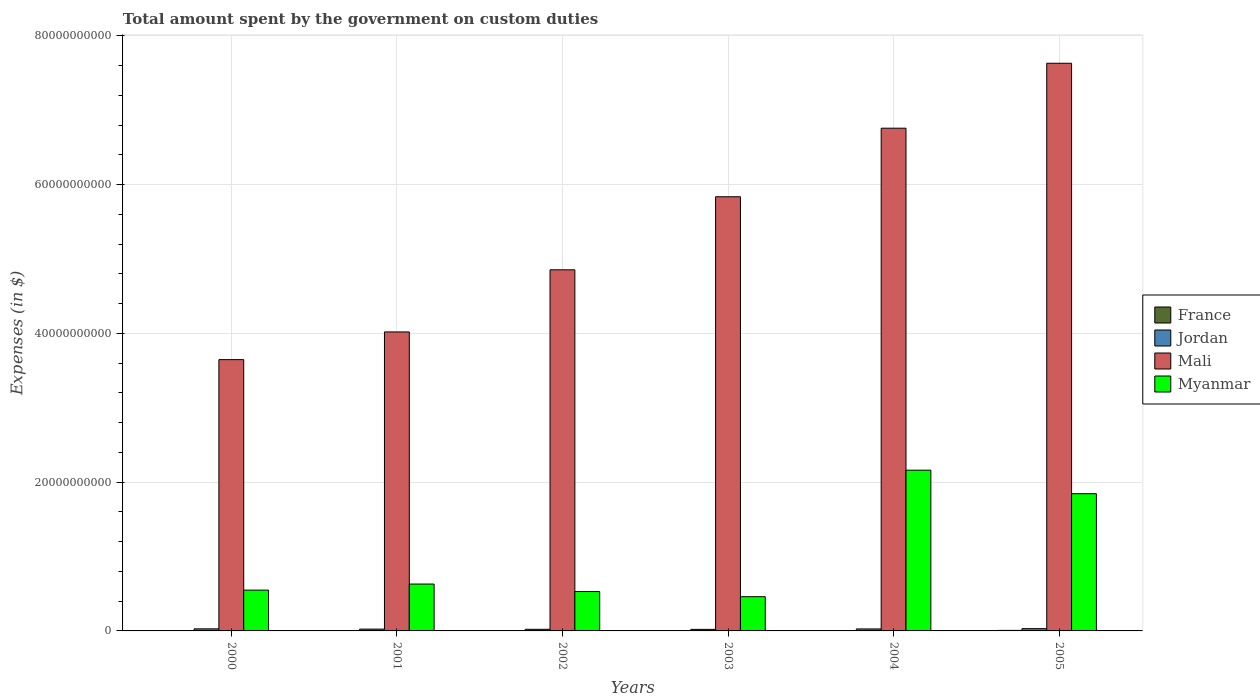How many different coloured bars are there?
Your response must be concise. 4. How many groups of bars are there?
Keep it short and to the point. 6. What is the label of the 4th group of bars from the left?
Provide a succinct answer. 2003. What is the amount spent on custom duties by the government in Mali in 2002?
Your answer should be compact. 4.86e+1. Across all years, what is the maximum amount spent on custom duties by the government in France?
Offer a terse response. 7.30e+07. Across all years, what is the minimum amount spent on custom duties by the government in Jordan?
Your response must be concise. 2.09e+08. What is the total amount spent on custom duties by the government in Myanmar in the graph?
Provide a short and direct response. 6.17e+1. What is the difference between the amount spent on custom duties by the government in Jordan in 2002 and that in 2004?
Ensure brevity in your answer.  -4.71e+07. What is the difference between the amount spent on custom duties by the government in Myanmar in 2003 and the amount spent on custom duties by the government in Jordan in 2004?
Give a very brief answer. 4.34e+09. What is the average amount spent on custom duties by the government in France per year?
Your response must be concise. 1.73e+07. In the year 2005, what is the difference between the amount spent on custom duties by the government in Myanmar and amount spent on custom duties by the government in Jordan?
Provide a short and direct response. 1.81e+1. What is the ratio of the amount spent on custom duties by the government in Myanmar in 2002 to that in 2003?
Provide a succinct answer. 1.15. Is the amount spent on custom duties by the government in Jordan in 2000 less than that in 2005?
Offer a terse response. Yes. Is the difference between the amount spent on custom duties by the government in Myanmar in 2002 and 2004 greater than the difference between the amount spent on custom duties by the government in Jordan in 2002 and 2004?
Ensure brevity in your answer.  No. What is the difference between the highest and the second highest amount spent on custom duties by the government in France?
Your answer should be compact. 5.40e+07. What is the difference between the highest and the lowest amount spent on custom duties by the government in Mali?
Your answer should be compact. 3.98e+1. Is it the case that in every year, the sum of the amount spent on custom duties by the government in Mali and amount spent on custom duties by the government in Jordan is greater than the sum of amount spent on custom duties by the government in Myanmar and amount spent on custom duties by the government in France?
Your answer should be very brief. Yes. How many bars are there?
Provide a short and direct response. 22. Are all the bars in the graph horizontal?
Give a very brief answer. No. What is the difference between two consecutive major ticks on the Y-axis?
Ensure brevity in your answer.  2.00e+1. Does the graph contain any zero values?
Offer a very short reply. Yes. Does the graph contain grids?
Give a very brief answer. Yes. Where does the legend appear in the graph?
Offer a terse response. Center right. How are the legend labels stacked?
Make the answer very short. Vertical. What is the title of the graph?
Your response must be concise. Total amount spent by the government on custom duties. What is the label or title of the Y-axis?
Provide a short and direct response. Expenses (in $). What is the Expenses (in $) of France in 2000?
Offer a terse response. 1.90e+07. What is the Expenses (in $) in Jordan in 2000?
Provide a short and direct response. 2.78e+08. What is the Expenses (in $) of Mali in 2000?
Ensure brevity in your answer.  3.65e+1. What is the Expenses (in $) of Myanmar in 2000?
Keep it short and to the point. 5.49e+09. What is the Expenses (in $) of France in 2001?
Ensure brevity in your answer.  7.00e+06. What is the Expenses (in $) of Jordan in 2001?
Give a very brief answer. 2.42e+08. What is the Expenses (in $) in Mali in 2001?
Your answer should be very brief. 4.02e+1. What is the Expenses (in $) of Myanmar in 2001?
Your answer should be very brief. 6.30e+09. What is the Expenses (in $) of Jordan in 2002?
Keep it short and to the point. 2.20e+08. What is the Expenses (in $) in Mali in 2002?
Ensure brevity in your answer.  4.86e+1. What is the Expenses (in $) of Myanmar in 2002?
Keep it short and to the point. 5.30e+09. What is the Expenses (in $) in Jordan in 2003?
Offer a very short reply. 2.09e+08. What is the Expenses (in $) of Mali in 2003?
Offer a terse response. 5.84e+1. What is the Expenses (in $) in Myanmar in 2003?
Offer a very short reply. 4.60e+09. What is the Expenses (in $) of Jordan in 2004?
Offer a very short reply. 2.67e+08. What is the Expenses (in $) of Mali in 2004?
Provide a short and direct response. 6.76e+1. What is the Expenses (in $) of Myanmar in 2004?
Ensure brevity in your answer.  2.16e+1. What is the Expenses (in $) in France in 2005?
Keep it short and to the point. 7.30e+07. What is the Expenses (in $) of Jordan in 2005?
Provide a short and direct response. 3.05e+08. What is the Expenses (in $) of Mali in 2005?
Your answer should be very brief. 7.63e+1. What is the Expenses (in $) in Myanmar in 2005?
Make the answer very short. 1.84e+1. Across all years, what is the maximum Expenses (in $) of France?
Your answer should be very brief. 7.30e+07. Across all years, what is the maximum Expenses (in $) of Jordan?
Your response must be concise. 3.05e+08. Across all years, what is the maximum Expenses (in $) in Mali?
Give a very brief answer. 7.63e+1. Across all years, what is the maximum Expenses (in $) of Myanmar?
Give a very brief answer. 2.16e+1. Across all years, what is the minimum Expenses (in $) in Jordan?
Ensure brevity in your answer.  2.09e+08. Across all years, what is the minimum Expenses (in $) in Mali?
Your response must be concise. 3.65e+1. Across all years, what is the minimum Expenses (in $) of Myanmar?
Keep it short and to the point. 4.60e+09. What is the total Expenses (in $) in France in the graph?
Your answer should be compact. 1.04e+08. What is the total Expenses (in $) in Jordan in the graph?
Your answer should be very brief. 1.52e+09. What is the total Expenses (in $) in Mali in the graph?
Your answer should be compact. 3.28e+11. What is the total Expenses (in $) in Myanmar in the graph?
Make the answer very short. 6.17e+1. What is the difference between the Expenses (in $) in Jordan in 2000 and that in 2001?
Offer a very short reply. 3.60e+07. What is the difference between the Expenses (in $) in Mali in 2000 and that in 2001?
Keep it short and to the point. -3.72e+09. What is the difference between the Expenses (in $) in Myanmar in 2000 and that in 2001?
Offer a terse response. -8.15e+08. What is the difference between the Expenses (in $) in France in 2000 and that in 2002?
Provide a succinct answer. 1.40e+07. What is the difference between the Expenses (in $) in Jordan in 2000 and that in 2002?
Offer a terse response. 5.82e+07. What is the difference between the Expenses (in $) in Mali in 2000 and that in 2002?
Provide a succinct answer. -1.21e+1. What is the difference between the Expenses (in $) in Myanmar in 2000 and that in 2002?
Ensure brevity in your answer.  1.91e+08. What is the difference between the Expenses (in $) in Jordan in 2000 and that in 2003?
Provide a succinct answer. 6.85e+07. What is the difference between the Expenses (in $) in Mali in 2000 and that in 2003?
Your answer should be very brief. -2.19e+1. What is the difference between the Expenses (in $) of Myanmar in 2000 and that in 2003?
Provide a succinct answer. 8.84e+08. What is the difference between the Expenses (in $) in Jordan in 2000 and that in 2004?
Provide a short and direct response. 1.11e+07. What is the difference between the Expenses (in $) of Mali in 2000 and that in 2004?
Offer a very short reply. -3.11e+1. What is the difference between the Expenses (in $) in Myanmar in 2000 and that in 2004?
Offer a terse response. -1.61e+1. What is the difference between the Expenses (in $) of France in 2000 and that in 2005?
Offer a terse response. -5.40e+07. What is the difference between the Expenses (in $) of Jordan in 2000 and that in 2005?
Keep it short and to the point. -2.69e+07. What is the difference between the Expenses (in $) in Mali in 2000 and that in 2005?
Provide a succinct answer. -3.98e+1. What is the difference between the Expenses (in $) of Myanmar in 2000 and that in 2005?
Provide a succinct answer. -1.30e+1. What is the difference between the Expenses (in $) in Jordan in 2001 and that in 2002?
Provide a succinct answer. 2.22e+07. What is the difference between the Expenses (in $) in Mali in 2001 and that in 2002?
Make the answer very short. -8.35e+09. What is the difference between the Expenses (in $) in Myanmar in 2001 and that in 2002?
Make the answer very short. 1.01e+09. What is the difference between the Expenses (in $) in Jordan in 2001 and that in 2003?
Provide a succinct answer. 3.25e+07. What is the difference between the Expenses (in $) of Mali in 2001 and that in 2003?
Offer a terse response. -1.82e+1. What is the difference between the Expenses (in $) of Myanmar in 2001 and that in 2003?
Give a very brief answer. 1.70e+09. What is the difference between the Expenses (in $) in Jordan in 2001 and that in 2004?
Ensure brevity in your answer.  -2.49e+07. What is the difference between the Expenses (in $) of Mali in 2001 and that in 2004?
Your answer should be very brief. -2.74e+1. What is the difference between the Expenses (in $) of Myanmar in 2001 and that in 2004?
Ensure brevity in your answer.  -1.53e+1. What is the difference between the Expenses (in $) in France in 2001 and that in 2005?
Offer a terse response. -6.60e+07. What is the difference between the Expenses (in $) of Jordan in 2001 and that in 2005?
Keep it short and to the point. -6.29e+07. What is the difference between the Expenses (in $) in Mali in 2001 and that in 2005?
Keep it short and to the point. -3.61e+1. What is the difference between the Expenses (in $) in Myanmar in 2001 and that in 2005?
Ensure brevity in your answer.  -1.21e+1. What is the difference between the Expenses (in $) of Jordan in 2002 and that in 2003?
Ensure brevity in your answer.  1.04e+07. What is the difference between the Expenses (in $) in Mali in 2002 and that in 2003?
Offer a very short reply. -9.82e+09. What is the difference between the Expenses (in $) of Myanmar in 2002 and that in 2003?
Keep it short and to the point. 6.93e+08. What is the difference between the Expenses (in $) in Jordan in 2002 and that in 2004?
Provide a succinct answer. -4.71e+07. What is the difference between the Expenses (in $) in Mali in 2002 and that in 2004?
Make the answer very short. -1.90e+1. What is the difference between the Expenses (in $) in Myanmar in 2002 and that in 2004?
Offer a terse response. -1.63e+1. What is the difference between the Expenses (in $) in France in 2002 and that in 2005?
Offer a very short reply. -6.80e+07. What is the difference between the Expenses (in $) in Jordan in 2002 and that in 2005?
Offer a terse response. -8.51e+07. What is the difference between the Expenses (in $) of Mali in 2002 and that in 2005?
Give a very brief answer. -2.78e+1. What is the difference between the Expenses (in $) in Myanmar in 2002 and that in 2005?
Provide a succinct answer. -1.32e+1. What is the difference between the Expenses (in $) in Jordan in 2003 and that in 2004?
Offer a terse response. -5.75e+07. What is the difference between the Expenses (in $) in Mali in 2003 and that in 2004?
Provide a succinct answer. -9.22e+09. What is the difference between the Expenses (in $) in Myanmar in 2003 and that in 2004?
Ensure brevity in your answer.  -1.70e+1. What is the difference between the Expenses (in $) of Jordan in 2003 and that in 2005?
Offer a very short reply. -9.54e+07. What is the difference between the Expenses (in $) of Mali in 2003 and that in 2005?
Your response must be concise. -1.79e+1. What is the difference between the Expenses (in $) in Myanmar in 2003 and that in 2005?
Ensure brevity in your answer.  -1.38e+1. What is the difference between the Expenses (in $) of Jordan in 2004 and that in 2005?
Your answer should be compact. -3.80e+07. What is the difference between the Expenses (in $) in Mali in 2004 and that in 2005?
Your response must be concise. -8.73e+09. What is the difference between the Expenses (in $) of Myanmar in 2004 and that in 2005?
Offer a very short reply. 3.16e+09. What is the difference between the Expenses (in $) in France in 2000 and the Expenses (in $) in Jordan in 2001?
Keep it short and to the point. -2.23e+08. What is the difference between the Expenses (in $) in France in 2000 and the Expenses (in $) in Mali in 2001?
Keep it short and to the point. -4.02e+1. What is the difference between the Expenses (in $) in France in 2000 and the Expenses (in $) in Myanmar in 2001?
Give a very brief answer. -6.28e+09. What is the difference between the Expenses (in $) of Jordan in 2000 and the Expenses (in $) of Mali in 2001?
Offer a terse response. -3.99e+1. What is the difference between the Expenses (in $) in Jordan in 2000 and the Expenses (in $) in Myanmar in 2001?
Your response must be concise. -6.02e+09. What is the difference between the Expenses (in $) in Mali in 2000 and the Expenses (in $) in Myanmar in 2001?
Your answer should be very brief. 3.02e+1. What is the difference between the Expenses (in $) of France in 2000 and the Expenses (in $) of Jordan in 2002?
Your answer should be very brief. -2.01e+08. What is the difference between the Expenses (in $) of France in 2000 and the Expenses (in $) of Mali in 2002?
Your answer should be very brief. -4.85e+1. What is the difference between the Expenses (in $) of France in 2000 and the Expenses (in $) of Myanmar in 2002?
Your answer should be very brief. -5.28e+09. What is the difference between the Expenses (in $) of Jordan in 2000 and the Expenses (in $) of Mali in 2002?
Offer a very short reply. -4.83e+1. What is the difference between the Expenses (in $) in Jordan in 2000 and the Expenses (in $) in Myanmar in 2002?
Your answer should be compact. -5.02e+09. What is the difference between the Expenses (in $) in Mali in 2000 and the Expenses (in $) in Myanmar in 2002?
Your answer should be compact. 3.12e+1. What is the difference between the Expenses (in $) of France in 2000 and the Expenses (in $) of Jordan in 2003?
Make the answer very short. -1.90e+08. What is the difference between the Expenses (in $) in France in 2000 and the Expenses (in $) in Mali in 2003?
Make the answer very short. -5.84e+1. What is the difference between the Expenses (in $) in France in 2000 and the Expenses (in $) in Myanmar in 2003?
Provide a short and direct response. -4.58e+09. What is the difference between the Expenses (in $) in Jordan in 2000 and the Expenses (in $) in Mali in 2003?
Provide a succinct answer. -5.81e+1. What is the difference between the Expenses (in $) in Jordan in 2000 and the Expenses (in $) in Myanmar in 2003?
Provide a short and direct response. -4.32e+09. What is the difference between the Expenses (in $) of Mali in 2000 and the Expenses (in $) of Myanmar in 2003?
Keep it short and to the point. 3.19e+1. What is the difference between the Expenses (in $) of France in 2000 and the Expenses (in $) of Jordan in 2004?
Keep it short and to the point. -2.48e+08. What is the difference between the Expenses (in $) of France in 2000 and the Expenses (in $) of Mali in 2004?
Your answer should be very brief. -6.76e+1. What is the difference between the Expenses (in $) in France in 2000 and the Expenses (in $) in Myanmar in 2004?
Your answer should be compact. -2.16e+1. What is the difference between the Expenses (in $) of Jordan in 2000 and the Expenses (in $) of Mali in 2004?
Provide a short and direct response. -6.73e+1. What is the difference between the Expenses (in $) in Jordan in 2000 and the Expenses (in $) in Myanmar in 2004?
Your answer should be very brief. -2.13e+1. What is the difference between the Expenses (in $) of Mali in 2000 and the Expenses (in $) of Myanmar in 2004?
Ensure brevity in your answer.  1.49e+1. What is the difference between the Expenses (in $) of France in 2000 and the Expenses (in $) of Jordan in 2005?
Your response must be concise. -2.86e+08. What is the difference between the Expenses (in $) of France in 2000 and the Expenses (in $) of Mali in 2005?
Ensure brevity in your answer.  -7.63e+1. What is the difference between the Expenses (in $) of France in 2000 and the Expenses (in $) of Myanmar in 2005?
Your answer should be very brief. -1.84e+1. What is the difference between the Expenses (in $) of Jordan in 2000 and the Expenses (in $) of Mali in 2005?
Offer a very short reply. -7.60e+1. What is the difference between the Expenses (in $) of Jordan in 2000 and the Expenses (in $) of Myanmar in 2005?
Your response must be concise. -1.82e+1. What is the difference between the Expenses (in $) in Mali in 2000 and the Expenses (in $) in Myanmar in 2005?
Provide a succinct answer. 1.80e+1. What is the difference between the Expenses (in $) in France in 2001 and the Expenses (in $) in Jordan in 2002?
Keep it short and to the point. -2.13e+08. What is the difference between the Expenses (in $) of France in 2001 and the Expenses (in $) of Mali in 2002?
Your answer should be very brief. -4.85e+1. What is the difference between the Expenses (in $) of France in 2001 and the Expenses (in $) of Myanmar in 2002?
Your answer should be very brief. -5.29e+09. What is the difference between the Expenses (in $) in Jordan in 2001 and the Expenses (in $) in Mali in 2002?
Your response must be concise. -4.83e+1. What is the difference between the Expenses (in $) in Jordan in 2001 and the Expenses (in $) in Myanmar in 2002?
Your answer should be compact. -5.05e+09. What is the difference between the Expenses (in $) in Mali in 2001 and the Expenses (in $) in Myanmar in 2002?
Ensure brevity in your answer.  3.49e+1. What is the difference between the Expenses (in $) in France in 2001 and the Expenses (in $) in Jordan in 2003?
Give a very brief answer. -2.02e+08. What is the difference between the Expenses (in $) in France in 2001 and the Expenses (in $) in Mali in 2003?
Provide a succinct answer. -5.84e+1. What is the difference between the Expenses (in $) in France in 2001 and the Expenses (in $) in Myanmar in 2003?
Provide a short and direct response. -4.60e+09. What is the difference between the Expenses (in $) in Jordan in 2001 and the Expenses (in $) in Mali in 2003?
Your response must be concise. -5.81e+1. What is the difference between the Expenses (in $) of Jordan in 2001 and the Expenses (in $) of Myanmar in 2003?
Your response must be concise. -4.36e+09. What is the difference between the Expenses (in $) of Mali in 2001 and the Expenses (in $) of Myanmar in 2003?
Provide a short and direct response. 3.56e+1. What is the difference between the Expenses (in $) of France in 2001 and the Expenses (in $) of Jordan in 2004?
Offer a terse response. -2.60e+08. What is the difference between the Expenses (in $) in France in 2001 and the Expenses (in $) in Mali in 2004?
Your answer should be compact. -6.76e+1. What is the difference between the Expenses (in $) in France in 2001 and the Expenses (in $) in Myanmar in 2004?
Offer a very short reply. -2.16e+1. What is the difference between the Expenses (in $) in Jordan in 2001 and the Expenses (in $) in Mali in 2004?
Your response must be concise. -6.73e+1. What is the difference between the Expenses (in $) of Jordan in 2001 and the Expenses (in $) of Myanmar in 2004?
Keep it short and to the point. -2.14e+1. What is the difference between the Expenses (in $) of Mali in 2001 and the Expenses (in $) of Myanmar in 2004?
Provide a short and direct response. 1.86e+1. What is the difference between the Expenses (in $) of France in 2001 and the Expenses (in $) of Jordan in 2005?
Your response must be concise. -2.98e+08. What is the difference between the Expenses (in $) in France in 2001 and the Expenses (in $) in Mali in 2005?
Offer a terse response. -7.63e+1. What is the difference between the Expenses (in $) in France in 2001 and the Expenses (in $) in Myanmar in 2005?
Ensure brevity in your answer.  -1.84e+1. What is the difference between the Expenses (in $) of Jordan in 2001 and the Expenses (in $) of Mali in 2005?
Your response must be concise. -7.61e+1. What is the difference between the Expenses (in $) of Jordan in 2001 and the Expenses (in $) of Myanmar in 2005?
Ensure brevity in your answer.  -1.82e+1. What is the difference between the Expenses (in $) of Mali in 2001 and the Expenses (in $) of Myanmar in 2005?
Make the answer very short. 2.18e+1. What is the difference between the Expenses (in $) of France in 2002 and the Expenses (in $) of Jordan in 2003?
Make the answer very short. -2.04e+08. What is the difference between the Expenses (in $) of France in 2002 and the Expenses (in $) of Mali in 2003?
Your answer should be very brief. -5.84e+1. What is the difference between the Expenses (in $) of France in 2002 and the Expenses (in $) of Myanmar in 2003?
Your response must be concise. -4.60e+09. What is the difference between the Expenses (in $) of Jordan in 2002 and the Expenses (in $) of Mali in 2003?
Ensure brevity in your answer.  -5.82e+1. What is the difference between the Expenses (in $) of Jordan in 2002 and the Expenses (in $) of Myanmar in 2003?
Keep it short and to the point. -4.38e+09. What is the difference between the Expenses (in $) of Mali in 2002 and the Expenses (in $) of Myanmar in 2003?
Provide a short and direct response. 4.40e+1. What is the difference between the Expenses (in $) of France in 2002 and the Expenses (in $) of Jordan in 2004?
Keep it short and to the point. -2.62e+08. What is the difference between the Expenses (in $) in France in 2002 and the Expenses (in $) in Mali in 2004?
Keep it short and to the point. -6.76e+1. What is the difference between the Expenses (in $) of France in 2002 and the Expenses (in $) of Myanmar in 2004?
Your response must be concise. -2.16e+1. What is the difference between the Expenses (in $) of Jordan in 2002 and the Expenses (in $) of Mali in 2004?
Provide a succinct answer. -6.74e+1. What is the difference between the Expenses (in $) in Jordan in 2002 and the Expenses (in $) in Myanmar in 2004?
Give a very brief answer. -2.14e+1. What is the difference between the Expenses (in $) of Mali in 2002 and the Expenses (in $) of Myanmar in 2004?
Ensure brevity in your answer.  2.69e+1. What is the difference between the Expenses (in $) in France in 2002 and the Expenses (in $) in Jordan in 2005?
Make the answer very short. -3.00e+08. What is the difference between the Expenses (in $) in France in 2002 and the Expenses (in $) in Mali in 2005?
Your response must be concise. -7.63e+1. What is the difference between the Expenses (in $) in France in 2002 and the Expenses (in $) in Myanmar in 2005?
Your answer should be very brief. -1.84e+1. What is the difference between the Expenses (in $) in Jordan in 2002 and the Expenses (in $) in Mali in 2005?
Provide a succinct answer. -7.61e+1. What is the difference between the Expenses (in $) of Jordan in 2002 and the Expenses (in $) of Myanmar in 2005?
Offer a very short reply. -1.82e+1. What is the difference between the Expenses (in $) of Mali in 2002 and the Expenses (in $) of Myanmar in 2005?
Offer a terse response. 3.01e+1. What is the difference between the Expenses (in $) of Jordan in 2003 and the Expenses (in $) of Mali in 2004?
Your answer should be very brief. -6.74e+1. What is the difference between the Expenses (in $) of Jordan in 2003 and the Expenses (in $) of Myanmar in 2004?
Keep it short and to the point. -2.14e+1. What is the difference between the Expenses (in $) of Mali in 2003 and the Expenses (in $) of Myanmar in 2004?
Your answer should be very brief. 3.68e+1. What is the difference between the Expenses (in $) in Jordan in 2003 and the Expenses (in $) in Mali in 2005?
Provide a short and direct response. -7.61e+1. What is the difference between the Expenses (in $) in Jordan in 2003 and the Expenses (in $) in Myanmar in 2005?
Provide a short and direct response. -1.82e+1. What is the difference between the Expenses (in $) of Mali in 2003 and the Expenses (in $) of Myanmar in 2005?
Your answer should be compact. 3.99e+1. What is the difference between the Expenses (in $) in Jordan in 2004 and the Expenses (in $) in Mali in 2005?
Give a very brief answer. -7.61e+1. What is the difference between the Expenses (in $) in Jordan in 2004 and the Expenses (in $) in Myanmar in 2005?
Offer a terse response. -1.82e+1. What is the difference between the Expenses (in $) in Mali in 2004 and the Expenses (in $) in Myanmar in 2005?
Your answer should be compact. 4.91e+1. What is the average Expenses (in $) of France per year?
Offer a very short reply. 1.73e+07. What is the average Expenses (in $) in Jordan per year?
Offer a terse response. 2.54e+08. What is the average Expenses (in $) in Mali per year?
Offer a very short reply. 5.46e+1. What is the average Expenses (in $) in Myanmar per year?
Provide a short and direct response. 1.03e+1. In the year 2000, what is the difference between the Expenses (in $) in France and Expenses (in $) in Jordan?
Your response must be concise. -2.59e+08. In the year 2000, what is the difference between the Expenses (in $) in France and Expenses (in $) in Mali?
Offer a terse response. -3.65e+1. In the year 2000, what is the difference between the Expenses (in $) in France and Expenses (in $) in Myanmar?
Offer a very short reply. -5.47e+09. In the year 2000, what is the difference between the Expenses (in $) in Jordan and Expenses (in $) in Mali?
Give a very brief answer. -3.62e+1. In the year 2000, what is the difference between the Expenses (in $) of Jordan and Expenses (in $) of Myanmar?
Provide a succinct answer. -5.21e+09. In the year 2000, what is the difference between the Expenses (in $) of Mali and Expenses (in $) of Myanmar?
Ensure brevity in your answer.  3.10e+1. In the year 2001, what is the difference between the Expenses (in $) in France and Expenses (in $) in Jordan?
Your answer should be compact. -2.35e+08. In the year 2001, what is the difference between the Expenses (in $) of France and Expenses (in $) of Mali?
Make the answer very short. -4.02e+1. In the year 2001, what is the difference between the Expenses (in $) of France and Expenses (in $) of Myanmar?
Ensure brevity in your answer.  -6.29e+09. In the year 2001, what is the difference between the Expenses (in $) of Jordan and Expenses (in $) of Mali?
Your answer should be compact. -4.00e+1. In the year 2001, what is the difference between the Expenses (in $) of Jordan and Expenses (in $) of Myanmar?
Give a very brief answer. -6.06e+09. In the year 2001, what is the difference between the Expenses (in $) in Mali and Expenses (in $) in Myanmar?
Provide a succinct answer. 3.39e+1. In the year 2002, what is the difference between the Expenses (in $) of France and Expenses (in $) of Jordan?
Provide a short and direct response. -2.15e+08. In the year 2002, what is the difference between the Expenses (in $) in France and Expenses (in $) in Mali?
Provide a short and direct response. -4.85e+1. In the year 2002, what is the difference between the Expenses (in $) of France and Expenses (in $) of Myanmar?
Provide a short and direct response. -5.29e+09. In the year 2002, what is the difference between the Expenses (in $) of Jordan and Expenses (in $) of Mali?
Keep it short and to the point. -4.83e+1. In the year 2002, what is the difference between the Expenses (in $) of Jordan and Expenses (in $) of Myanmar?
Your answer should be very brief. -5.08e+09. In the year 2002, what is the difference between the Expenses (in $) in Mali and Expenses (in $) in Myanmar?
Your answer should be compact. 4.33e+1. In the year 2003, what is the difference between the Expenses (in $) in Jordan and Expenses (in $) in Mali?
Your answer should be compact. -5.82e+1. In the year 2003, what is the difference between the Expenses (in $) in Jordan and Expenses (in $) in Myanmar?
Offer a very short reply. -4.39e+09. In the year 2003, what is the difference between the Expenses (in $) of Mali and Expenses (in $) of Myanmar?
Ensure brevity in your answer.  5.38e+1. In the year 2004, what is the difference between the Expenses (in $) in Jordan and Expenses (in $) in Mali?
Ensure brevity in your answer.  -6.73e+1. In the year 2004, what is the difference between the Expenses (in $) of Jordan and Expenses (in $) of Myanmar?
Keep it short and to the point. -2.13e+1. In the year 2004, what is the difference between the Expenses (in $) of Mali and Expenses (in $) of Myanmar?
Make the answer very short. 4.60e+1. In the year 2005, what is the difference between the Expenses (in $) in France and Expenses (in $) in Jordan?
Offer a very short reply. -2.32e+08. In the year 2005, what is the difference between the Expenses (in $) in France and Expenses (in $) in Mali?
Ensure brevity in your answer.  -7.63e+1. In the year 2005, what is the difference between the Expenses (in $) in France and Expenses (in $) in Myanmar?
Your answer should be very brief. -1.84e+1. In the year 2005, what is the difference between the Expenses (in $) of Jordan and Expenses (in $) of Mali?
Provide a short and direct response. -7.60e+1. In the year 2005, what is the difference between the Expenses (in $) in Jordan and Expenses (in $) in Myanmar?
Ensure brevity in your answer.  -1.81e+1. In the year 2005, what is the difference between the Expenses (in $) in Mali and Expenses (in $) in Myanmar?
Provide a succinct answer. 5.79e+1. What is the ratio of the Expenses (in $) in France in 2000 to that in 2001?
Keep it short and to the point. 2.71. What is the ratio of the Expenses (in $) of Jordan in 2000 to that in 2001?
Your answer should be very brief. 1.15. What is the ratio of the Expenses (in $) in Mali in 2000 to that in 2001?
Make the answer very short. 0.91. What is the ratio of the Expenses (in $) in Myanmar in 2000 to that in 2001?
Make the answer very short. 0.87. What is the ratio of the Expenses (in $) of France in 2000 to that in 2002?
Your answer should be very brief. 3.8. What is the ratio of the Expenses (in $) in Jordan in 2000 to that in 2002?
Your answer should be very brief. 1.26. What is the ratio of the Expenses (in $) in Mali in 2000 to that in 2002?
Provide a short and direct response. 0.75. What is the ratio of the Expenses (in $) in Myanmar in 2000 to that in 2002?
Give a very brief answer. 1.04. What is the ratio of the Expenses (in $) of Jordan in 2000 to that in 2003?
Your answer should be very brief. 1.33. What is the ratio of the Expenses (in $) in Mali in 2000 to that in 2003?
Ensure brevity in your answer.  0.62. What is the ratio of the Expenses (in $) of Myanmar in 2000 to that in 2003?
Offer a terse response. 1.19. What is the ratio of the Expenses (in $) of Jordan in 2000 to that in 2004?
Your answer should be compact. 1.04. What is the ratio of the Expenses (in $) in Mali in 2000 to that in 2004?
Offer a very short reply. 0.54. What is the ratio of the Expenses (in $) in Myanmar in 2000 to that in 2004?
Provide a succinct answer. 0.25. What is the ratio of the Expenses (in $) in France in 2000 to that in 2005?
Provide a short and direct response. 0.26. What is the ratio of the Expenses (in $) in Jordan in 2000 to that in 2005?
Provide a succinct answer. 0.91. What is the ratio of the Expenses (in $) in Mali in 2000 to that in 2005?
Ensure brevity in your answer.  0.48. What is the ratio of the Expenses (in $) in Myanmar in 2000 to that in 2005?
Offer a very short reply. 0.3. What is the ratio of the Expenses (in $) of Jordan in 2001 to that in 2002?
Your answer should be compact. 1.1. What is the ratio of the Expenses (in $) in Mali in 2001 to that in 2002?
Make the answer very short. 0.83. What is the ratio of the Expenses (in $) of Myanmar in 2001 to that in 2002?
Provide a succinct answer. 1.19. What is the ratio of the Expenses (in $) in Jordan in 2001 to that in 2003?
Your answer should be very brief. 1.16. What is the ratio of the Expenses (in $) in Mali in 2001 to that in 2003?
Make the answer very short. 0.69. What is the ratio of the Expenses (in $) of Myanmar in 2001 to that in 2003?
Ensure brevity in your answer.  1.37. What is the ratio of the Expenses (in $) in Jordan in 2001 to that in 2004?
Provide a short and direct response. 0.91. What is the ratio of the Expenses (in $) of Mali in 2001 to that in 2004?
Keep it short and to the point. 0.59. What is the ratio of the Expenses (in $) in Myanmar in 2001 to that in 2004?
Your answer should be compact. 0.29. What is the ratio of the Expenses (in $) of France in 2001 to that in 2005?
Ensure brevity in your answer.  0.1. What is the ratio of the Expenses (in $) of Jordan in 2001 to that in 2005?
Ensure brevity in your answer.  0.79. What is the ratio of the Expenses (in $) in Mali in 2001 to that in 2005?
Make the answer very short. 0.53. What is the ratio of the Expenses (in $) in Myanmar in 2001 to that in 2005?
Your answer should be very brief. 0.34. What is the ratio of the Expenses (in $) of Jordan in 2002 to that in 2003?
Offer a terse response. 1.05. What is the ratio of the Expenses (in $) of Mali in 2002 to that in 2003?
Provide a short and direct response. 0.83. What is the ratio of the Expenses (in $) of Myanmar in 2002 to that in 2003?
Offer a very short reply. 1.15. What is the ratio of the Expenses (in $) of Jordan in 2002 to that in 2004?
Provide a short and direct response. 0.82. What is the ratio of the Expenses (in $) of Mali in 2002 to that in 2004?
Your response must be concise. 0.72. What is the ratio of the Expenses (in $) of Myanmar in 2002 to that in 2004?
Provide a succinct answer. 0.24. What is the ratio of the Expenses (in $) of France in 2002 to that in 2005?
Make the answer very short. 0.07. What is the ratio of the Expenses (in $) in Jordan in 2002 to that in 2005?
Your answer should be compact. 0.72. What is the ratio of the Expenses (in $) of Mali in 2002 to that in 2005?
Your answer should be compact. 0.64. What is the ratio of the Expenses (in $) of Myanmar in 2002 to that in 2005?
Provide a succinct answer. 0.29. What is the ratio of the Expenses (in $) of Jordan in 2003 to that in 2004?
Ensure brevity in your answer.  0.78. What is the ratio of the Expenses (in $) in Mali in 2003 to that in 2004?
Offer a terse response. 0.86. What is the ratio of the Expenses (in $) of Myanmar in 2003 to that in 2004?
Provide a short and direct response. 0.21. What is the ratio of the Expenses (in $) of Jordan in 2003 to that in 2005?
Ensure brevity in your answer.  0.69. What is the ratio of the Expenses (in $) in Mali in 2003 to that in 2005?
Provide a succinct answer. 0.76. What is the ratio of the Expenses (in $) in Myanmar in 2003 to that in 2005?
Provide a short and direct response. 0.25. What is the ratio of the Expenses (in $) of Jordan in 2004 to that in 2005?
Your answer should be compact. 0.88. What is the ratio of the Expenses (in $) of Mali in 2004 to that in 2005?
Provide a succinct answer. 0.89. What is the ratio of the Expenses (in $) of Myanmar in 2004 to that in 2005?
Keep it short and to the point. 1.17. What is the difference between the highest and the second highest Expenses (in $) of France?
Offer a very short reply. 5.40e+07. What is the difference between the highest and the second highest Expenses (in $) of Jordan?
Keep it short and to the point. 2.69e+07. What is the difference between the highest and the second highest Expenses (in $) in Mali?
Give a very brief answer. 8.73e+09. What is the difference between the highest and the second highest Expenses (in $) in Myanmar?
Offer a very short reply. 3.16e+09. What is the difference between the highest and the lowest Expenses (in $) in France?
Give a very brief answer. 7.30e+07. What is the difference between the highest and the lowest Expenses (in $) of Jordan?
Give a very brief answer. 9.54e+07. What is the difference between the highest and the lowest Expenses (in $) of Mali?
Provide a succinct answer. 3.98e+1. What is the difference between the highest and the lowest Expenses (in $) of Myanmar?
Make the answer very short. 1.70e+1. 